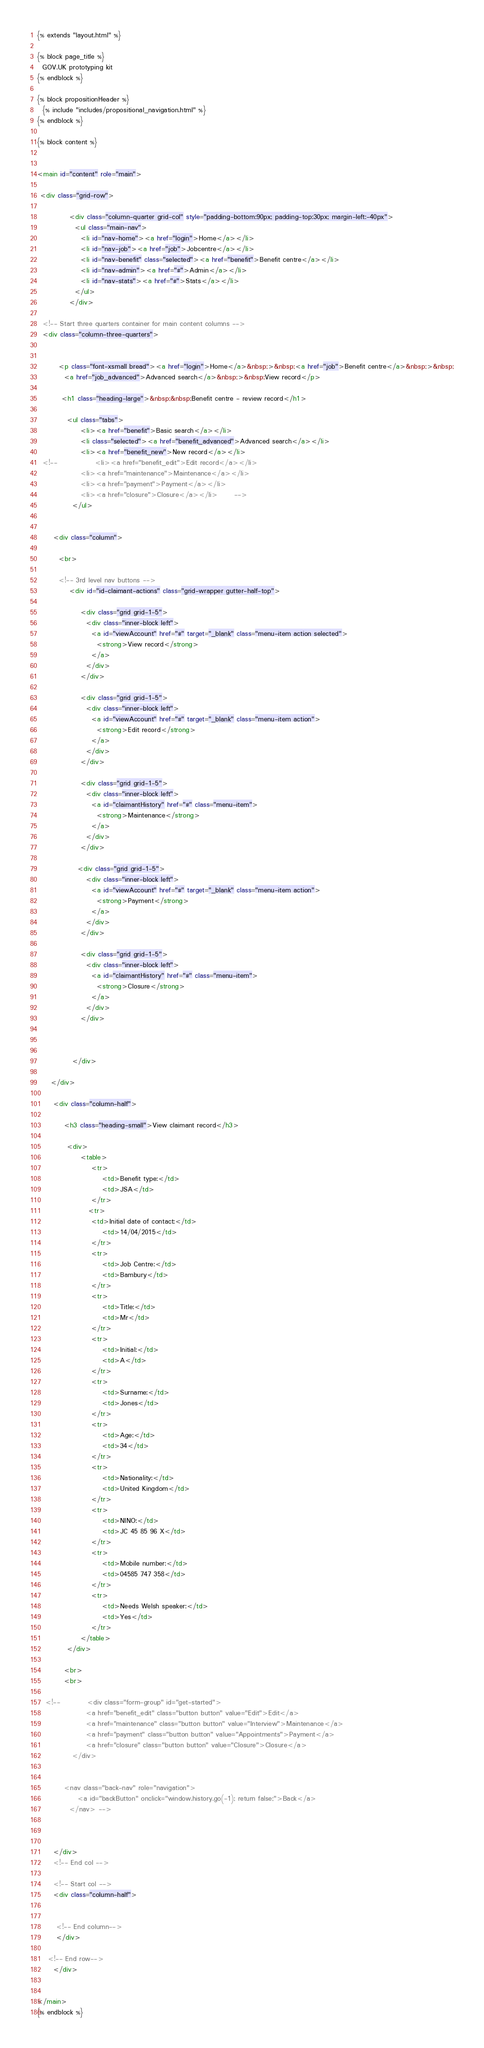<code> <loc_0><loc_0><loc_500><loc_500><_HTML_>{% extends "layout.html" %}

{% block page_title %}
  GOV.UK prototyping kit
{% endblock %}

{% block propositionHeader %}
  {% include "includes/propositional_navigation.html" %}
{% endblock %}

{% block content %}


<main id="content" role="main">

 <div class="grid-row">        

            <div class="column-quarter grid-col" style="padding-bottom:90px; padding-top:30px; margin-left:-40px">
              <ul class="main-nav">
                <li id="nav-home"><a href="login">Home</a></li>
                <li id="nav-job"><a href="job">Jobcentre</a></li>
                <li id="nav-benefit" class="selected"><a href="benefit">Benefit centre</a></li>
                <li id="nav-admin"><a href="#">Admin</a></li>
                <li id="nav-stats"><a href="#">Stats</a></li>
              </ul>
            </div>

  <!-- Start three quarters container for main content columns -->
  <div class="column-three-quarters">


        <p class="font-xsmall bread"><a href="login">Home</a>&nbsp;>&nbsp;<a href="job">Benefit centre</a>&nbsp;>&nbsp;
          <a href="job_advanced">Advanced search</a>&nbsp;>&nbsp;View record</p> 

         <h1 class="heading-large">&nbsp;&nbsp;Benefit centre - review record</h1>

           <ul class="tabs">
                <li><a href="benefit">Basic search</a></li>
                <li class="selected"><a href="benefit_advanced">Advanced search</a></li>
                <li><a href="benefit_new">New record</a></li>
  <!--              <li><a href="benefit_edit">Edit record</a></li>
                <li><a href="maintenance">Maintenance</a></li>
                <li><a href="payment">Payment</a></li>
                <li><a href="closure">Closure</a></li>      -->  
             </ul> 


      <div class="column">   

        <br>

        <!-- 3rd level nav buttons -->
            <div id="id-claimant-actions" class="grid-wrapper gutter-half-top">

                <div class="grid grid-1-5">
                  <div class="inner-block left">
                    <a id="viewAccount" href="#" target="_blank" class="menu-item action selected">
                      <strong>View record</strong>
                    </a>
                  </div>
                </div>

                <div class="grid grid-1-5">
                  <div class="inner-block left">
                    <a id="viewAccount" href="#" target="_blank" class="menu-item action">
                      <strong>Edit record</strong>
                    </a>
                  </div>
                </div>

                <div class="grid grid-1-5">
                  <div class="inner-block left">
                    <a id="claimantHistory" href="#" class="menu-item">
                      <strong>Maintenance</strong>
                    </a>
                  </div>
                </div>

               <div class="grid grid-1-5">
                  <div class="inner-block left">
                    <a id="viewAccount" href="#" target="_blank" class="menu-item action">
                      <strong>Payment</strong>
                    </a>
                  </div>
                </div>

                <div class="grid grid-1-5">
                  <div class="inner-block left">
                    <a id="claimantHistory" href="#" class="menu-item">
                      <strong>Closure</strong>
                    </a>
                  </div>
                </div>

                

             </div> 

     </div>   

      <div class="column-half">   

          <h3 class="heading-small">View claimant record</h3>

           <div>
                <table>
                    <tr>
                        <td>Benefit type:</td>
                        <td>JSA</td>
                    </tr>
                   <tr>
                    <td>Initial date of contact:</td>
                        <td>14/04/2015</td>
                    </tr>
                    <tr>
                        <td>Job Centre:</td>
                        <td>Bambury</td>
                    </tr>
                    <tr>
                        <td>Title:</td>
                        <td>Mr</td>
                    </tr>
                    <tr>
                        <td>Initial:</td>
                        <td>A</td>
                    </tr>
                    <tr>
                        <td>Surname:</td>
                        <td>Jones</td>
                    </tr>
                    <tr>
                        <td>Age:</td>
                        <td>34</td>
                    </tr>
                    <tr>
                        <td>Nationality:</td>
                        <td>United Kingdom</td>
                    </tr>
                    <tr>
                        <td>NINO:</td>
                        <td>JC 45 85 96 X</td>
                    </tr>
                    <tr>
                        <td>Mobile number:</td>
                        <td>04585 747 358</td>
                    </tr>
                    <tr>
                        <td>Needs Welsh speaker:</td>
                        <td>Yes</td>
                    </tr>
                </table>
           </div> 

          <br>
          <br>
     
   <!--          <div class="form-group" id="get-started">
                  <a href="benefit_edit" class="button button" value="Edit">Edit</a>
                  <a href="maintenance" class="button button" value="Interview">Maintenance</a>
                  <a href="payment" class="button button" value="Appointments">Payment</a>
                  <a href="closure" class="button button" value="Closure">Closure</a>
             </div> 


          <nav class="back-nav" role="navigation">
               <a id="backButton" onclick="window.history.go(-1); return false;">Back</a> 
            </nav> -->


         
      </div>
      <!-- End col -->

      <!-- Start col -->      
      <div class="column-half">    
        

       <!-- End column-->       
       </div>

    <!-- End row-->       
      </div>


</main>
{% endblock %}



</code> 